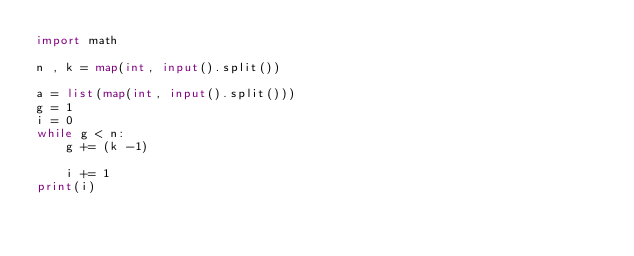<code> <loc_0><loc_0><loc_500><loc_500><_Python_>import math 

n , k = map(int, input().split())

a = list(map(int, input().split()))
g = 1 
i = 0
while g < n:
    g += (k -1)

    i += 1
print(i)</code> 